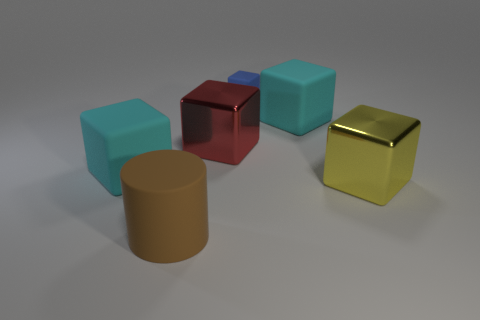Subtract all yellow metal blocks. How many blocks are left? 4 Add 1 purple matte things. How many objects exist? 7 Subtract all blue cubes. How many cubes are left? 4 Subtract all cubes. How many objects are left? 1 Subtract 3 cubes. How many cubes are left? 2 Subtract all yellow cylinders. Subtract all cyan spheres. How many cylinders are left? 1 Subtract 0 gray spheres. How many objects are left? 6 Subtract all green spheres. How many blue blocks are left? 1 Subtract all tiny blue rubber blocks. Subtract all big blocks. How many objects are left? 1 Add 4 yellow shiny cubes. How many yellow shiny cubes are left? 5 